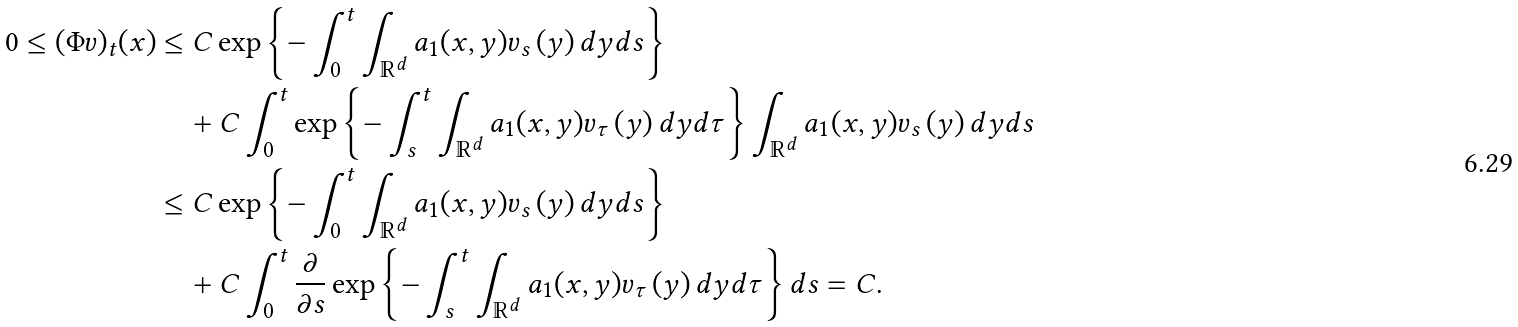Convert formula to latex. <formula><loc_0><loc_0><loc_500><loc_500>0 \leq ( \Phi v ) _ { t } ( x ) & \leq C \exp \left \{ - \int _ { 0 } ^ { t } \int _ { \mathbb { R } ^ { d } } a _ { 1 } ( x , y ) v _ { s } \left ( y \right ) d y d s \right \} \\ & \quad + C \int _ { 0 } ^ { t } \exp \left \{ - \int _ { s } ^ { t } \int _ { \mathbb { R } ^ { d } } a _ { 1 } ( x , y ) v _ { \tau } \left ( y \right ) d y d \tau \right \} \int _ { \mathbb { R } ^ { d } } a _ { 1 } ( x , y ) v _ { s } \left ( y \right ) d y d s \\ & \leq C \exp \left \{ - \int _ { 0 } ^ { t } \int _ { \mathbb { R } ^ { d } } a _ { 1 } ( x , y ) v _ { s } \left ( y \right ) d y d s \right \} \\ & \quad + C \int _ { 0 } ^ { t } \frac { \partial } { \partial s } \exp \left \{ - \int _ { s } ^ { t } \int _ { \mathbb { R } ^ { d } } a _ { 1 } ( x , y ) v _ { \tau } \left ( y \right ) d y d \tau \right \} d s = C .</formula> 